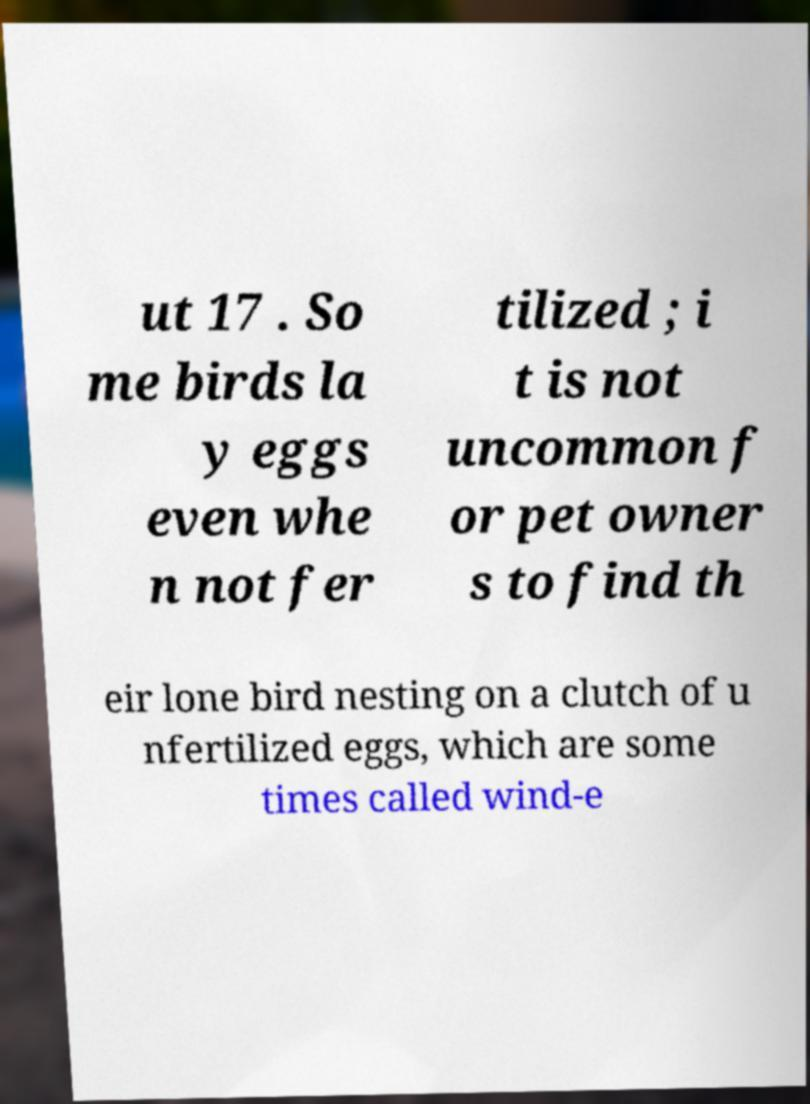Could you assist in decoding the text presented in this image and type it out clearly? ut 17 . So me birds la y eggs even whe n not fer tilized ; i t is not uncommon f or pet owner s to find th eir lone bird nesting on a clutch of u nfertilized eggs, which are some times called wind-e 